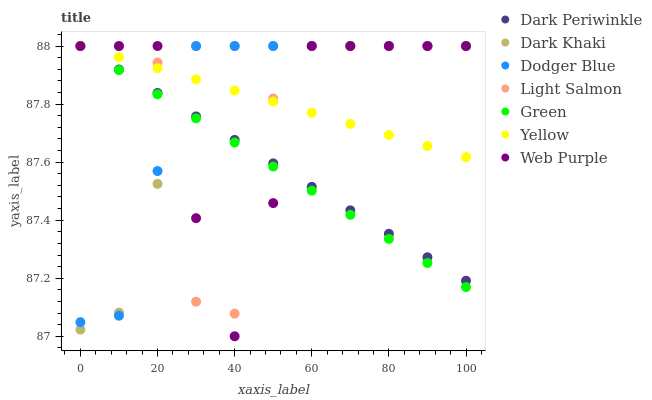Does Green have the minimum area under the curve?
Answer yes or no. Yes. Does Dodger Blue have the maximum area under the curve?
Answer yes or no. Yes. Does Yellow have the minimum area under the curve?
Answer yes or no. No. Does Yellow have the maximum area under the curve?
Answer yes or no. No. Is Green the smoothest?
Answer yes or no. Yes. Is Light Salmon the roughest?
Answer yes or no. Yes. Is Yellow the smoothest?
Answer yes or no. No. Is Yellow the roughest?
Answer yes or no. No. Does Web Purple have the lowest value?
Answer yes or no. Yes. Does Dark Khaki have the lowest value?
Answer yes or no. No. Does Dark Periwinkle have the highest value?
Answer yes or no. Yes. Does Dodger Blue intersect Web Purple?
Answer yes or no. Yes. Is Dodger Blue less than Web Purple?
Answer yes or no. No. Is Dodger Blue greater than Web Purple?
Answer yes or no. No. 